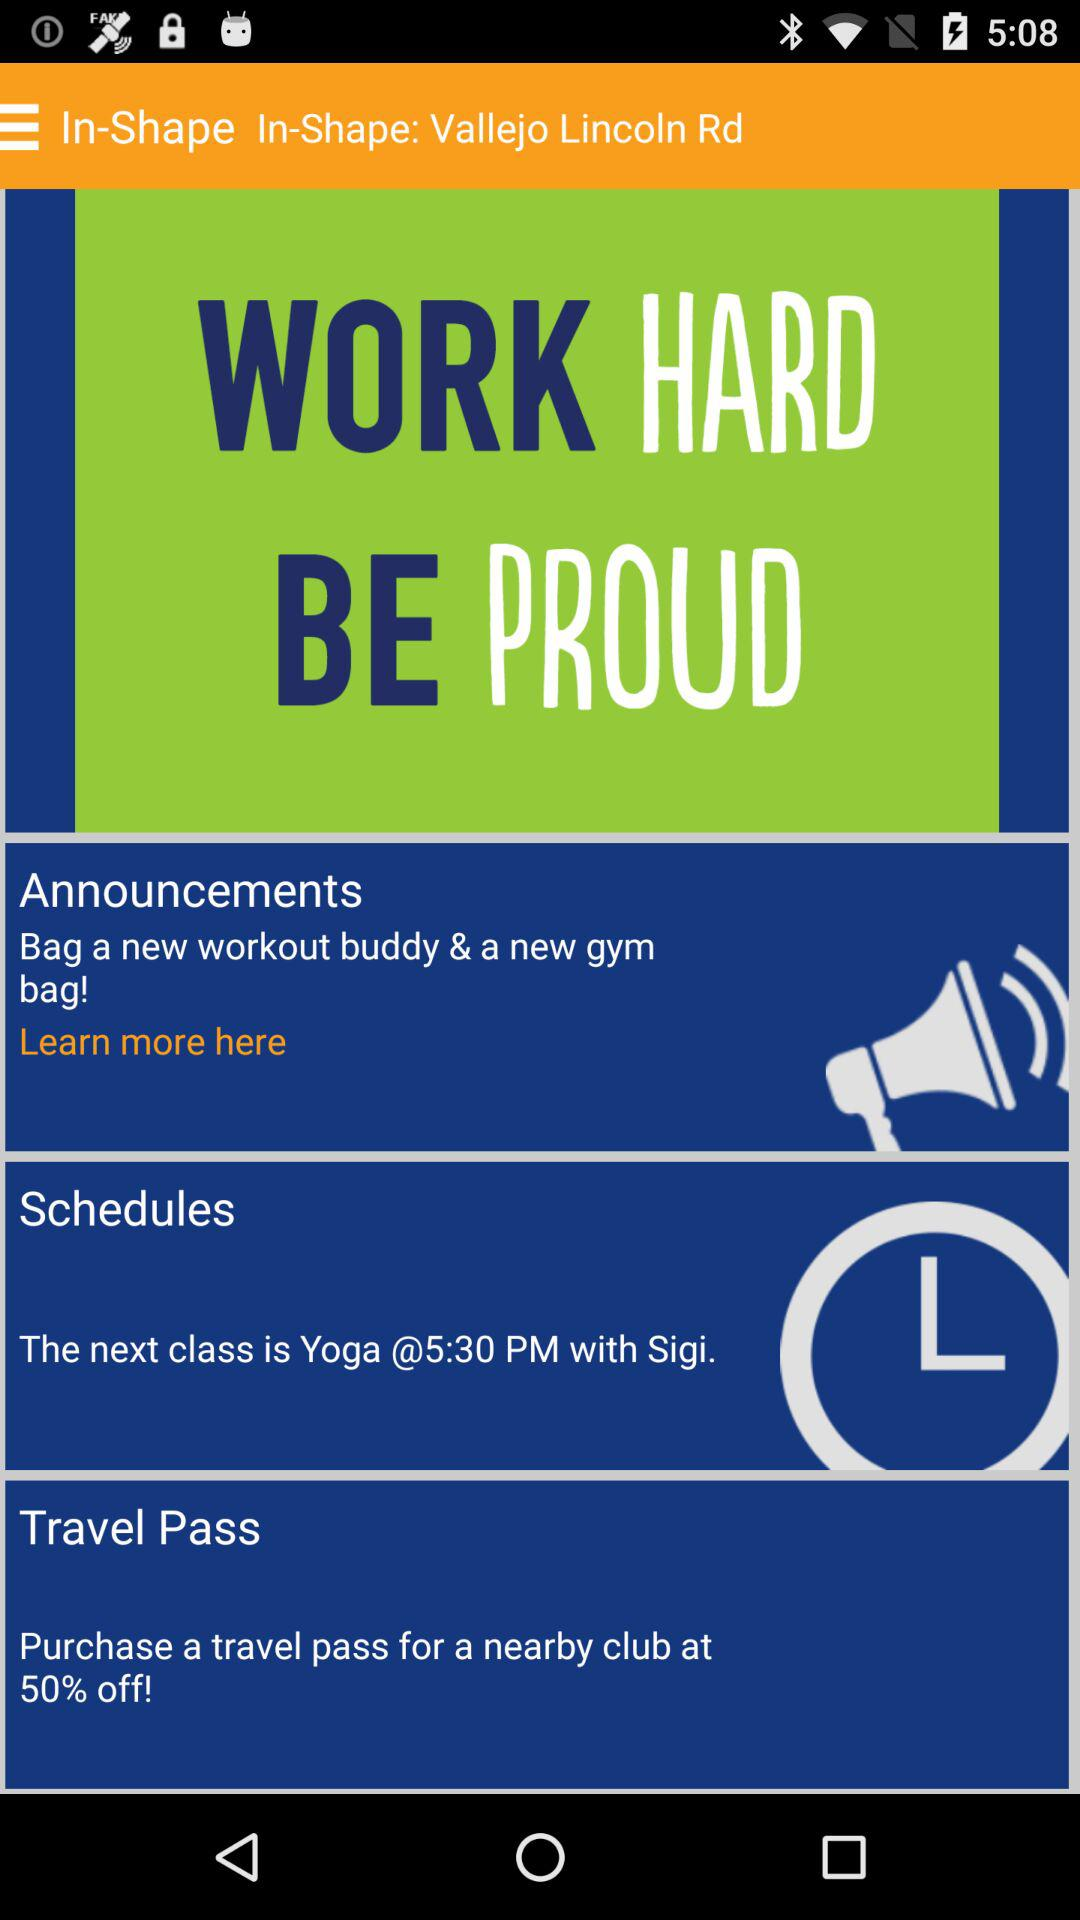How much of a discount is applicable on a travel pass? A discount of 50% is applicable on a travel pass. 